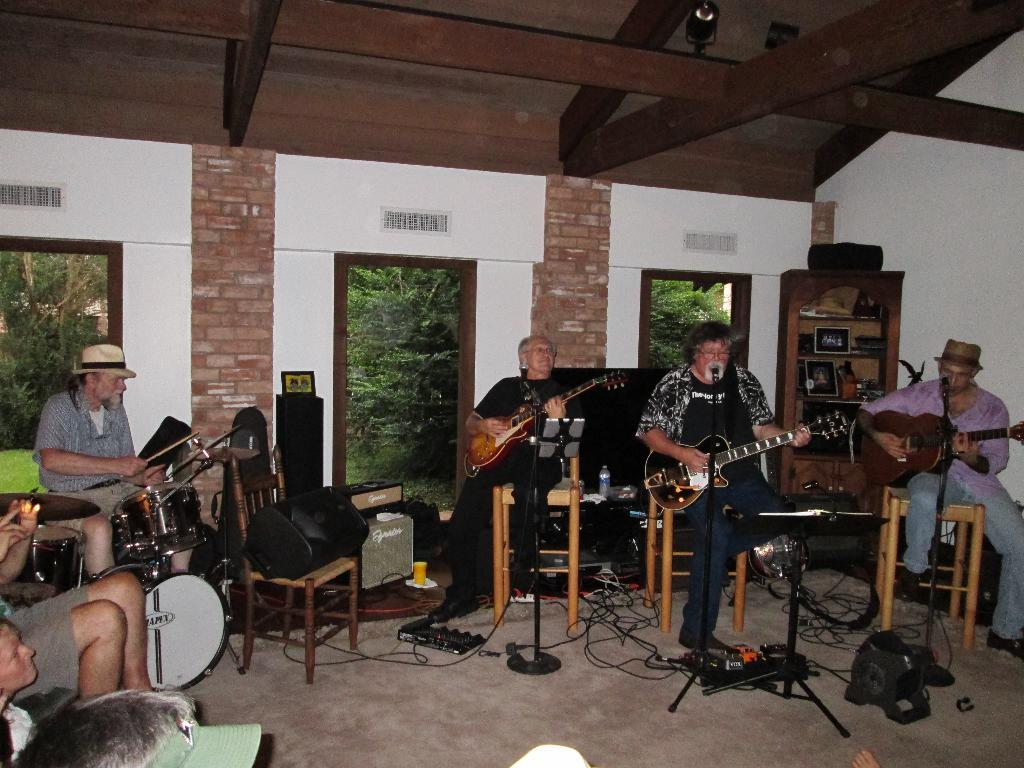What are the people in the image doing? The people in the image are sitting on chairs and playing musical instruments. What specific instruments can be seen in the image? Some people are holding guitars, and there are people playing a drum set. What type of bean is being used as a chin rest for the violin in the image? There is no violin or bean present in the image; the people are playing guitars and a drum set. 